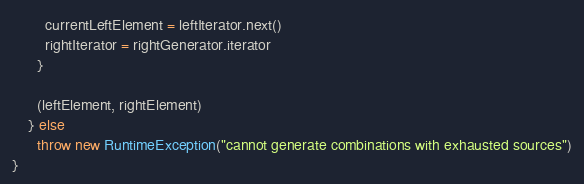<code> <loc_0><loc_0><loc_500><loc_500><_Scala_>        currentLeftElement = leftIterator.next()
        rightIterator = rightGenerator.iterator
      }

      (leftElement, rightElement)
    } else
      throw new RuntimeException("cannot generate combinations with exhausted sources")
}
</code> 